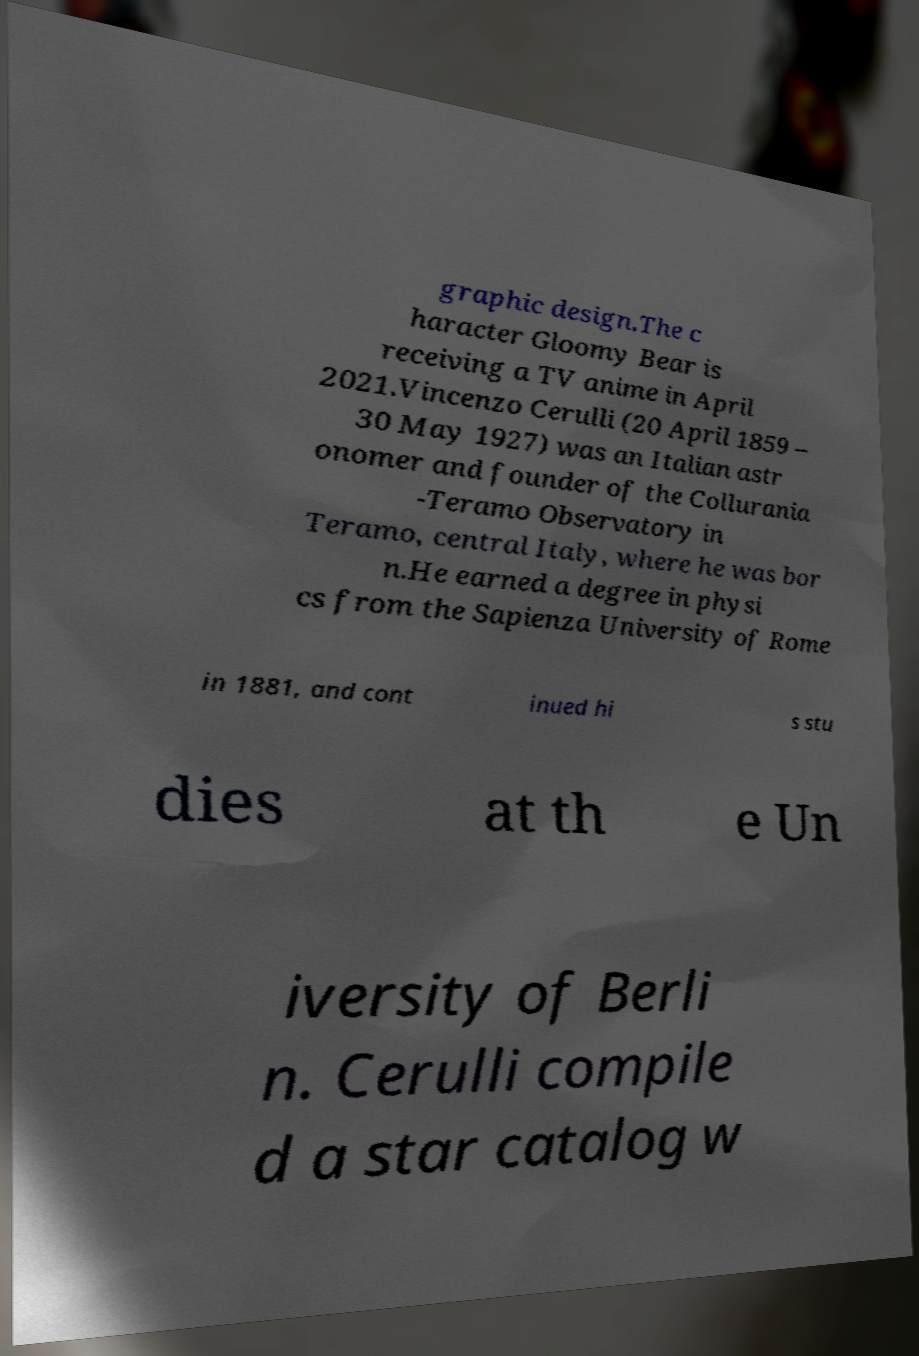I need the written content from this picture converted into text. Can you do that? graphic design.The c haracter Gloomy Bear is receiving a TV anime in April 2021.Vincenzo Cerulli (20 April 1859 – 30 May 1927) was an Italian astr onomer and founder of the Collurania -Teramo Observatory in Teramo, central Italy, where he was bor n.He earned a degree in physi cs from the Sapienza University of Rome in 1881, and cont inued hi s stu dies at th e Un iversity of Berli n. Cerulli compile d a star catalog w 